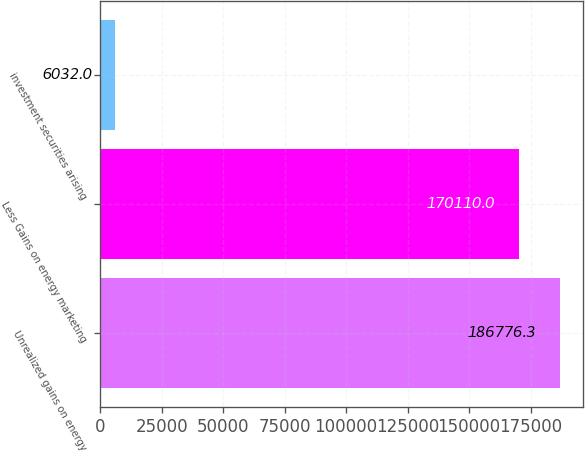<chart> <loc_0><loc_0><loc_500><loc_500><bar_chart><fcel>Unrealized gains on energy<fcel>Less Gains on energy marketing<fcel>investment securities arising<nl><fcel>186776<fcel>170110<fcel>6032<nl></chart> 